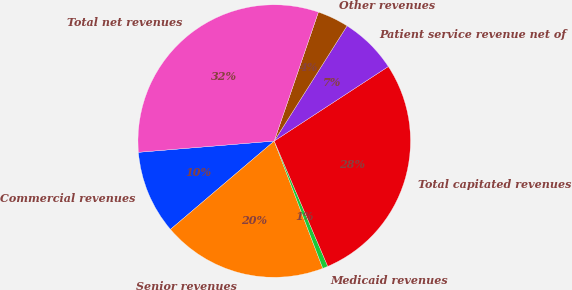<chart> <loc_0><loc_0><loc_500><loc_500><pie_chart><fcel>Commercial revenues<fcel>Senior revenues<fcel>Medicaid revenues<fcel>Total capitated revenues<fcel>Patient service revenue net of<fcel>Other revenues<fcel>Total net revenues<nl><fcel>9.91%<fcel>19.57%<fcel>0.63%<fcel>27.78%<fcel>6.82%<fcel>3.72%<fcel>31.57%<nl></chart> 